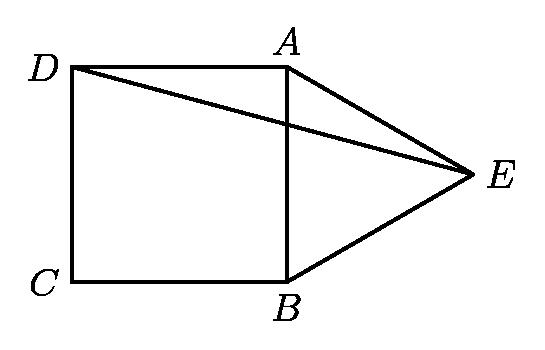If point E were to move and create different geometric figures with ABCD, what types of figures could be formed? If point E were to move, you could form a variety of geometric figures with ABCD. For example, if E moved to the midpoint of BC, you'd form a rectangle and two right triangles. If E were moved to lie on line AC, you could form a larger triangle. The possibilities depend on how E is positioned relative to the square. 